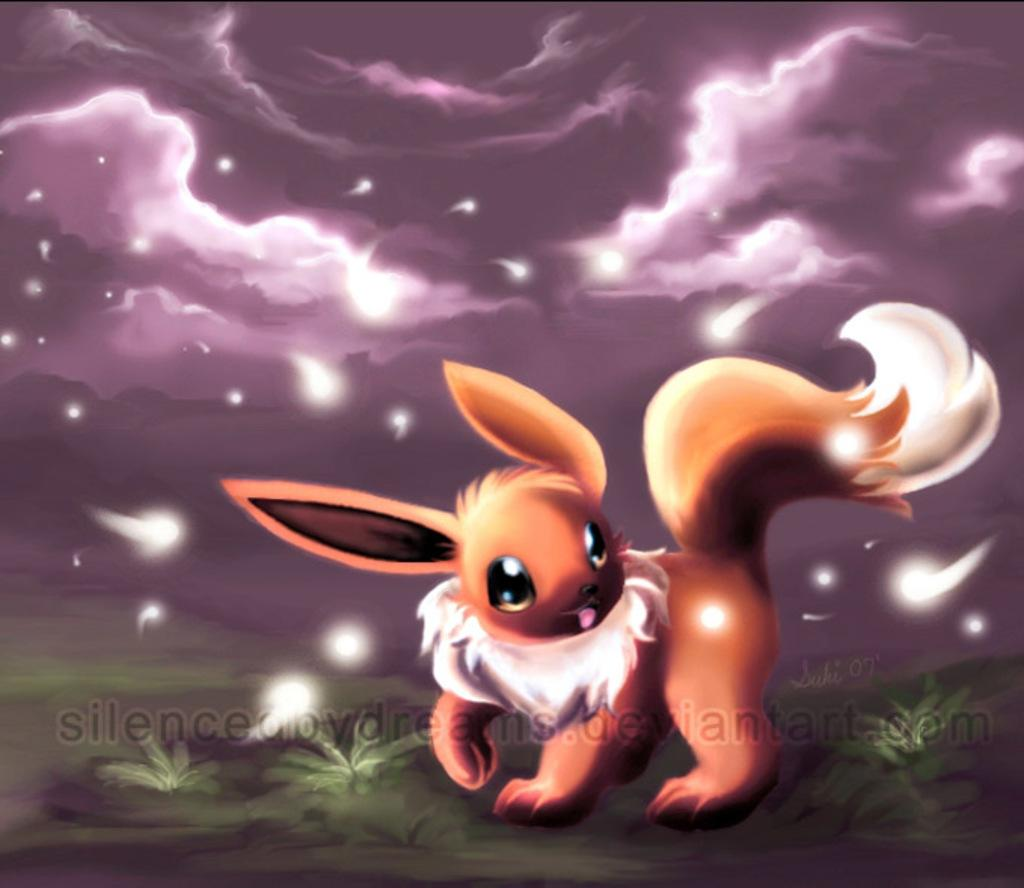What type of image is being described? The image appears to be animated. What kind of creature is present in the image? There is an animal in the image. What type of terrain is visible in the image? There is grass in the image. What can be seen in the sky in the image? There are clouds in the sky. What celestial objects are visible in the image? There are stars in the image. What type of bird is singing "Happy Birthday" in the image? There is no bird present in the image, nor is there any indication of a birthday celebration. 